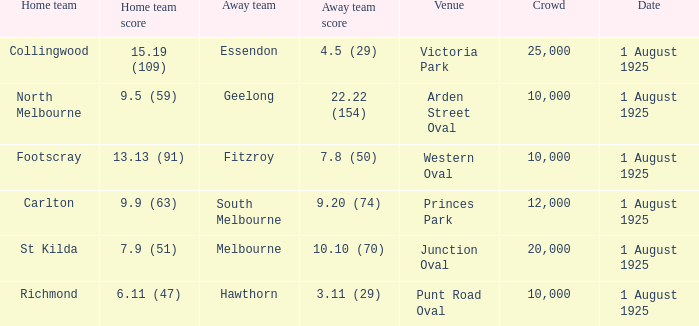Which match where Hawthorn was the away team had the largest crowd? 10000.0. 